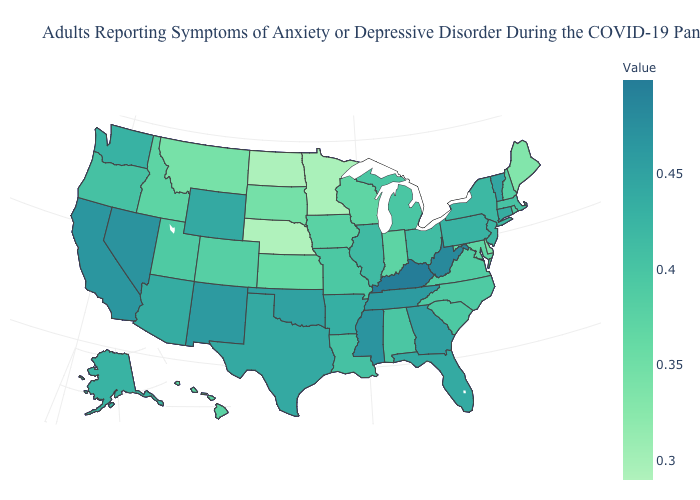Which states have the lowest value in the Northeast?
Be succinct. Maine. Does Kentucky have the highest value in the USA?
Give a very brief answer. Yes. Does Wyoming have the lowest value in the USA?
Answer briefly. No. Among the states that border California , does Arizona have the highest value?
Concise answer only. No. Is the legend a continuous bar?
Write a very short answer. Yes. Which states have the lowest value in the MidWest?
Write a very short answer. Nebraska. Does Alaska have a lower value than Montana?
Concise answer only. No. Does Kentucky have the highest value in the South?
Give a very brief answer. Yes. 